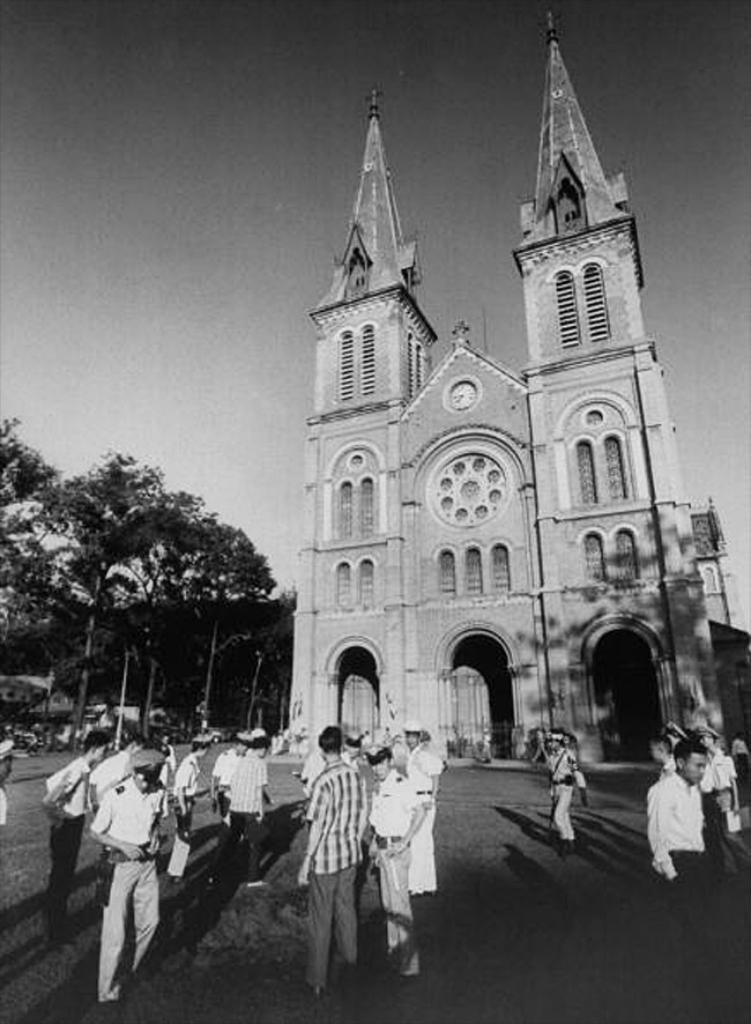How many people are present in the image? There are many people in the image. What can be seen in the background of the image? There is a building and trees in the background of the image. What is at the bottom of the image? There is a road at the bottom of the image. What is visible at the top of the image? The sky is visible at the top of the image. What type of heart can be seen in the image? There is no heart present in the image. What type of bushes are visible in the alley in the image? There is no alley or bushes present in the image. 